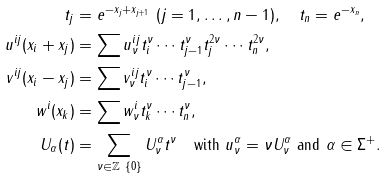<formula> <loc_0><loc_0><loc_500><loc_500>t _ { j } & = e ^ { - x _ { j } + x _ { j + 1 } } \ ( j = 1 , \dots , n - 1 ) , \quad t _ { n } = e ^ { - x _ { n } } , \\ u ^ { i j } ( x _ { i } + x _ { j } ) & = \sum u ^ { i j } _ { \nu } t _ { i } ^ { \nu } \cdots t _ { j - 1 } ^ { \nu } t _ { j } ^ { 2 \nu } \cdots t _ { n } ^ { 2 \nu } , \\ v ^ { i j } ( x _ { i } - x _ { j } ) & = \sum v ^ { i j } _ { \nu } t _ { i } ^ { \nu } \cdots t _ { j - 1 } ^ { \nu } , \\ w ^ { i } ( x _ { k } ) & = \sum w ^ { i } _ { \nu } t _ { k } ^ { \nu } \cdots t _ { n } ^ { \nu } , \\ U _ { \alpha } ( t ) & = \sum _ { \nu \in \mathbb { Z } \ \{ 0 \} } U ^ { \alpha } _ { \nu } t ^ { \nu } \quad \text {with } u ^ { \alpha } _ { \nu } = \nu U ^ { \alpha } _ { \nu } \text { and } \alpha \in \Sigma ^ { + } .</formula> 